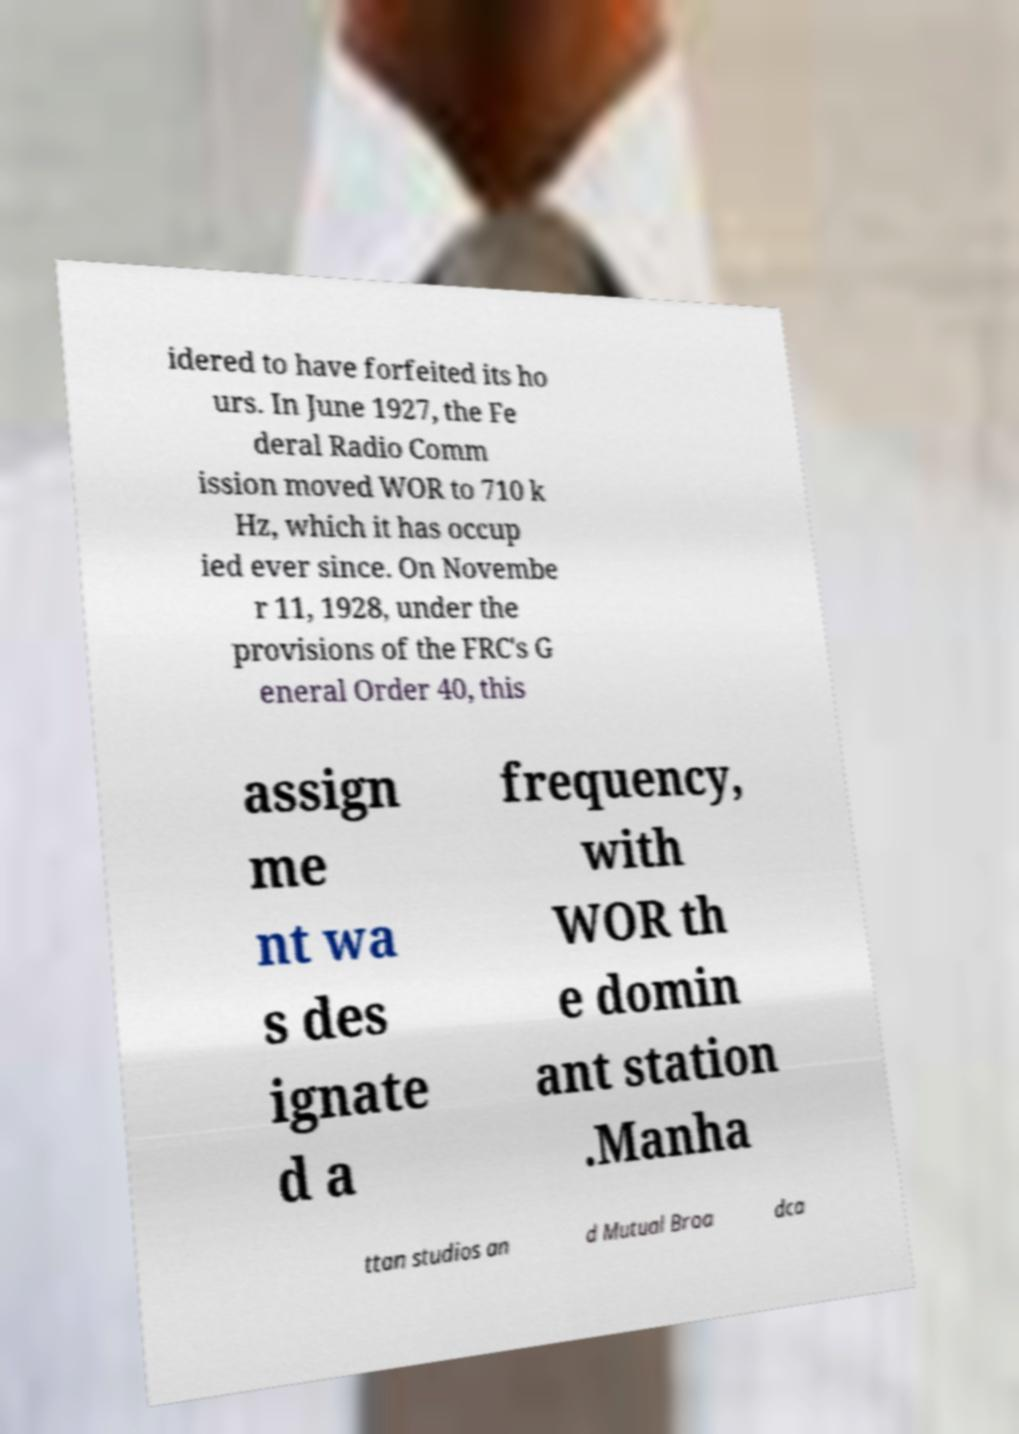What messages or text are displayed in this image? I need them in a readable, typed format. idered to have forfeited its ho urs. In June 1927, the Fe deral Radio Comm ission moved WOR to 710 k Hz, which it has occup ied ever since. On Novembe r 11, 1928, under the provisions of the FRC's G eneral Order 40, this assign me nt wa s des ignate d a frequency, with WOR th e domin ant station .Manha ttan studios an d Mutual Broa dca 